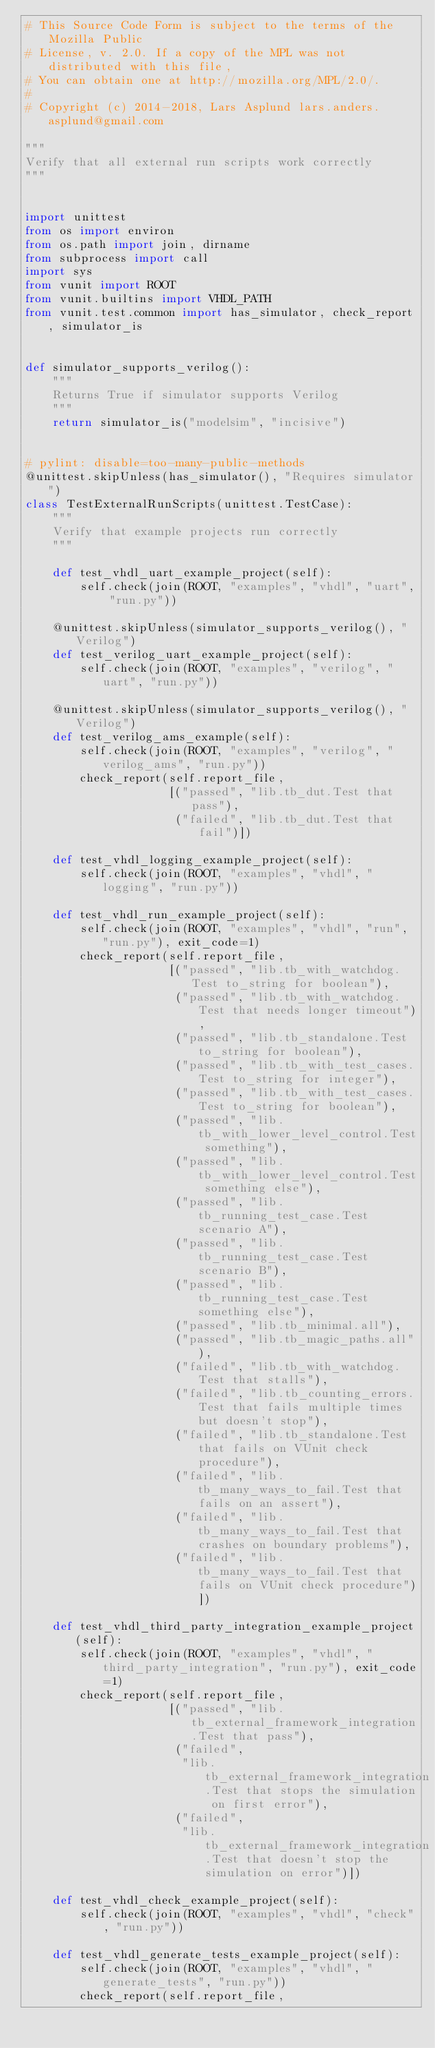<code> <loc_0><loc_0><loc_500><loc_500><_Python_># This Source Code Form is subject to the terms of the Mozilla Public
# License, v. 2.0. If a copy of the MPL was not distributed with this file,
# You can obtain one at http://mozilla.org/MPL/2.0/.
#
# Copyright (c) 2014-2018, Lars Asplund lars.anders.asplund@gmail.com

"""
Verify that all external run scripts work correctly
"""


import unittest
from os import environ
from os.path import join, dirname
from subprocess import call
import sys
from vunit import ROOT
from vunit.builtins import VHDL_PATH
from vunit.test.common import has_simulator, check_report, simulator_is


def simulator_supports_verilog():
    """
    Returns True if simulator supports Verilog
    """
    return simulator_is("modelsim", "incisive")


# pylint: disable=too-many-public-methods
@unittest.skipUnless(has_simulator(), "Requires simulator")
class TestExternalRunScripts(unittest.TestCase):
    """
    Verify that example projects run correctly
    """

    def test_vhdl_uart_example_project(self):
        self.check(join(ROOT, "examples", "vhdl", "uart", "run.py"))

    @unittest.skipUnless(simulator_supports_verilog(), "Verilog")
    def test_verilog_uart_example_project(self):
        self.check(join(ROOT, "examples", "verilog", "uart", "run.py"))

    @unittest.skipUnless(simulator_supports_verilog(), "Verilog")
    def test_verilog_ams_example(self):
        self.check(join(ROOT, "examples", "verilog", "verilog_ams", "run.py"))
        check_report(self.report_file,
                     [("passed", "lib.tb_dut.Test that pass"),
                      ("failed", "lib.tb_dut.Test that fail")])

    def test_vhdl_logging_example_project(self):
        self.check(join(ROOT, "examples", "vhdl", "logging", "run.py"))

    def test_vhdl_run_example_project(self):
        self.check(join(ROOT, "examples", "vhdl", "run", "run.py"), exit_code=1)
        check_report(self.report_file,
                     [("passed", "lib.tb_with_watchdog.Test to_string for boolean"),
                      ("passed", "lib.tb_with_watchdog.Test that needs longer timeout"),
                      ("passed", "lib.tb_standalone.Test to_string for boolean"),
                      ("passed", "lib.tb_with_test_cases.Test to_string for integer"),
                      ("passed", "lib.tb_with_test_cases.Test to_string for boolean"),
                      ("passed", "lib.tb_with_lower_level_control.Test something"),
                      ("passed", "lib.tb_with_lower_level_control.Test something else"),
                      ("passed", "lib.tb_running_test_case.Test scenario A"),
                      ("passed", "lib.tb_running_test_case.Test scenario B"),
                      ("passed", "lib.tb_running_test_case.Test something else"),
                      ("passed", "lib.tb_minimal.all"),
                      ("passed", "lib.tb_magic_paths.all"),
                      ("failed", "lib.tb_with_watchdog.Test that stalls"),
                      ("failed", "lib.tb_counting_errors.Test that fails multiple times but doesn't stop"),
                      ("failed", "lib.tb_standalone.Test that fails on VUnit check procedure"),
                      ("failed", "lib.tb_many_ways_to_fail.Test that fails on an assert"),
                      ("failed", "lib.tb_many_ways_to_fail.Test that crashes on boundary problems"),
                      ("failed", "lib.tb_many_ways_to_fail.Test that fails on VUnit check procedure")])

    def test_vhdl_third_party_integration_example_project(self):
        self.check(join(ROOT, "examples", "vhdl", "third_party_integration", "run.py"), exit_code=1)
        check_report(self.report_file,
                     [("passed", "lib.tb_external_framework_integration.Test that pass"),
                      ("failed",
                       "lib.tb_external_framework_integration.Test that stops the simulation on first error"),
                      ("failed",
                       "lib.tb_external_framework_integration.Test that doesn't stop the simulation on error")])

    def test_vhdl_check_example_project(self):
        self.check(join(ROOT, "examples", "vhdl", "check", "run.py"))

    def test_vhdl_generate_tests_example_project(self):
        self.check(join(ROOT, "examples", "vhdl", "generate_tests", "run.py"))
        check_report(self.report_file,</code> 